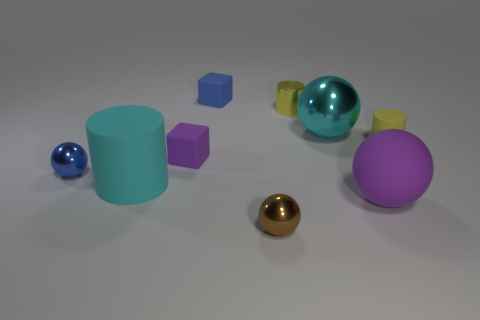Subtract all large cyan balls. How many balls are left? 3 Subtract all cyan cylinders. How many cylinders are left? 2 Subtract all yellow spheres. How many yellow cylinders are left? 2 Add 1 small yellow matte cubes. How many objects exist? 10 Subtract all spheres. How many objects are left? 5 Subtract 1 blocks. How many blocks are left? 1 Subtract all red cubes. Subtract all blue balls. How many cubes are left? 2 Subtract all tiny cubes. Subtract all small brown metal spheres. How many objects are left? 6 Add 4 cyan matte objects. How many cyan matte objects are left? 5 Add 8 tiny purple rubber cubes. How many tiny purple rubber cubes exist? 9 